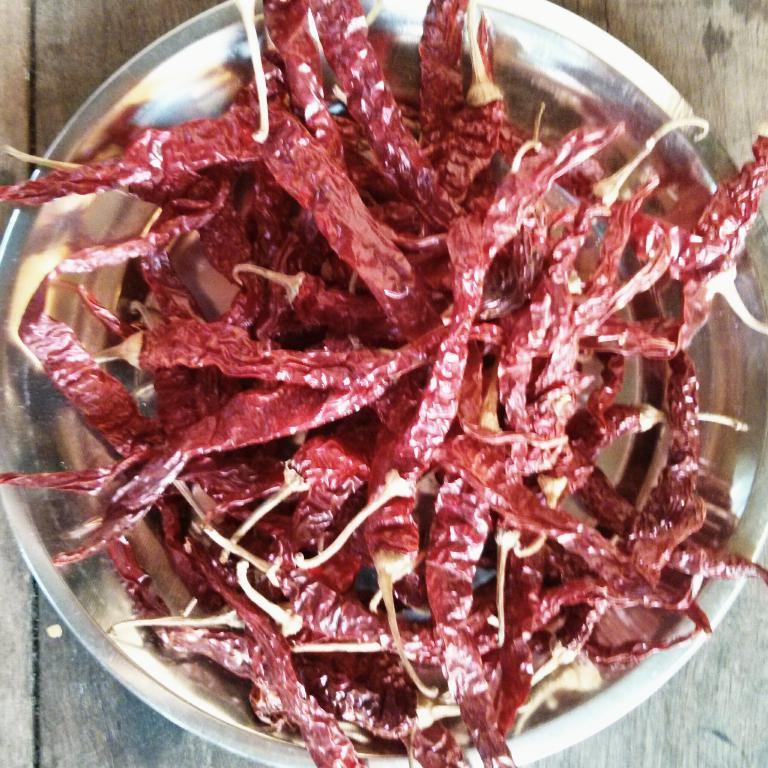What type of food item is present in the image? There are red dry chillies in the image. How are the red dry chillies arranged in the image? The red dry chillies are on a plate. What is the surface on which the plate is placed? The plate is on a wooden table. What direction are the red dry chillies facing in the image? The direction in which the red dry chillies are facing cannot be determined from the image, as they are not shown in a specific orientation. 